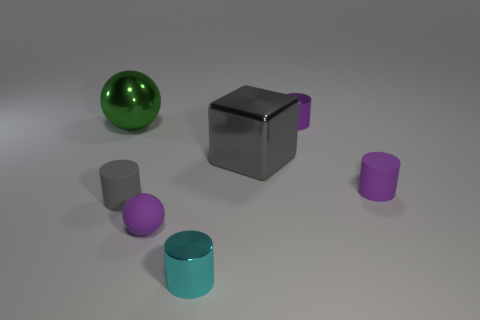Add 2 rubber cylinders. How many objects exist? 9 Subtract all gray cylinders. How many cylinders are left? 3 Subtract all gray cylinders. How many cylinders are left? 3 Subtract 1 spheres. How many spheres are left? 1 Subtract all blocks. How many objects are left? 6 Subtract all yellow balls. How many brown blocks are left? 0 Subtract all big green objects. Subtract all big cubes. How many objects are left? 5 Add 4 small matte cylinders. How many small matte cylinders are left? 6 Add 5 gray rubber cylinders. How many gray rubber cylinders exist? 6 Subtract 0 red blocks. How many objects are left? 7 